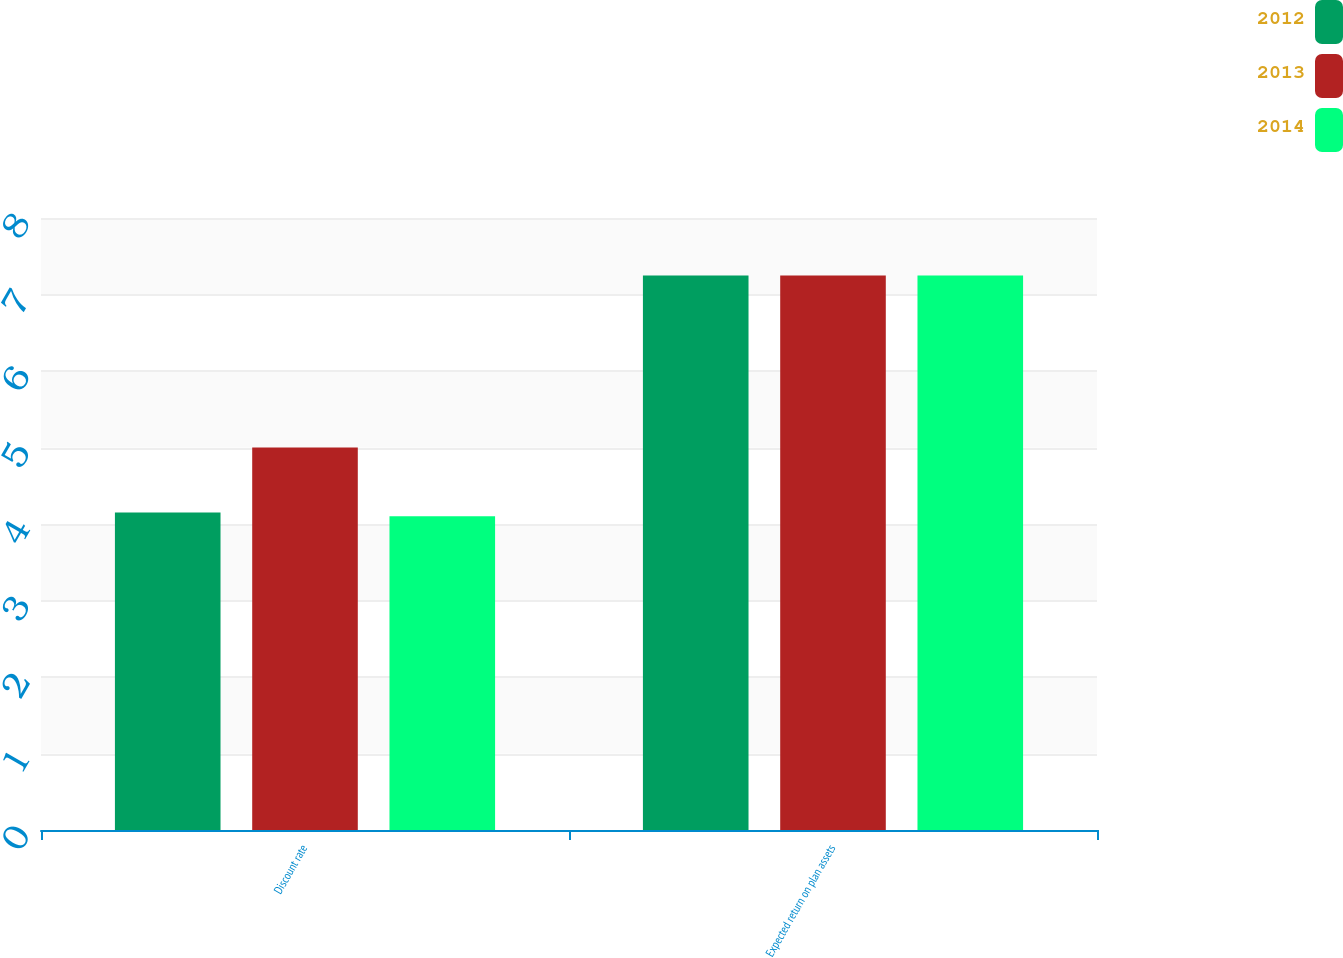<chart> <loc_0><loc_0><loc_500><loc_500><stacked_bar_chart><ecel><fcel>Discount rate<fcel>Expected return on plan assets<nl><fcel>2012<fcel>4.15<fcel>7.25<nl><fcel>2013<fcel>5<fcel>7.25<nl><fcel>2014<fcel>4.1<fcel>7.25<nl></chart> 